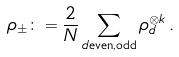<formula> <loc_0><loc_0><loc_500><loc_500>\rho _ { \pm } \colon = \frac { 2 } { N } \sum _ { d \text {even,odd} } \rho _ { d } ^ { \otimes k } \, .</formula> 